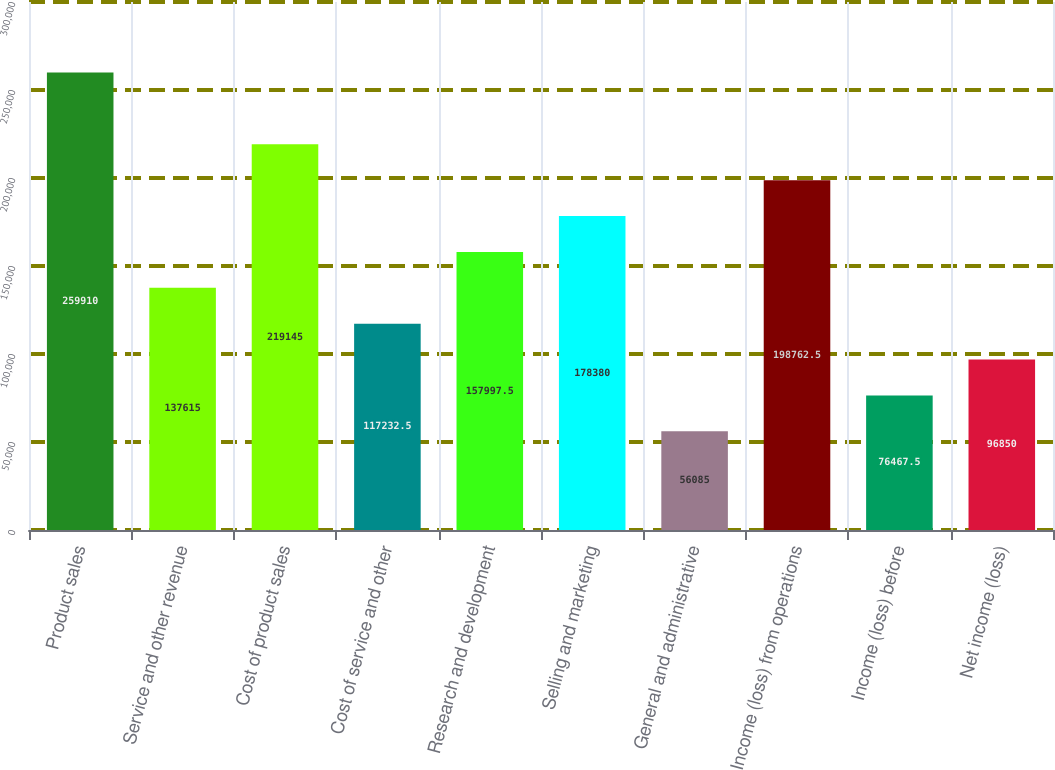Convert chart. <chart><loc_0><loc_0><loc_500><loc_500><bar_chart><fcel>Product sales<fcel>Service and other revenue<fcel>Cost of product sales<fcel>Cost of service and other<fcel>Research and development<fcel>Selling and marketing<fcel>General and administrative<fcel>Income (loss) from operations<fcel>Income (loss) before<fcel>Net income (loss)<nl><fcel>259910<fcel>137615<fcel>219145<fcel>117232<fcel>157998<fcel>178380<fcel>56085<fcel>198762<fcel>76467.5<fcel>96850<nl></chart> 